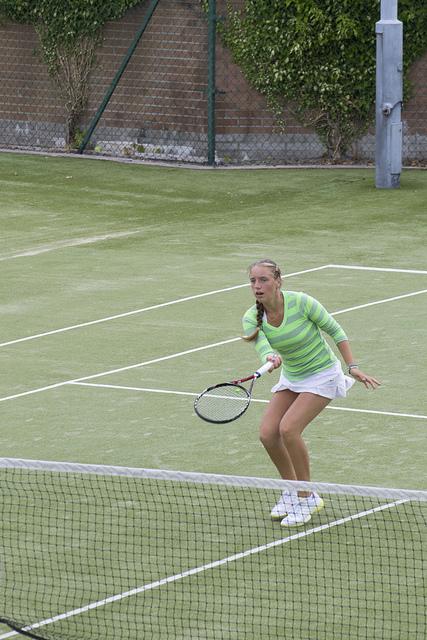What sport is the lady playing?
Short answer required. Tennis. Is the girl wearing slippers?
Keep it brief. No. What is the pattern on the player's shirt?
Write a very short answer. Stripes. 